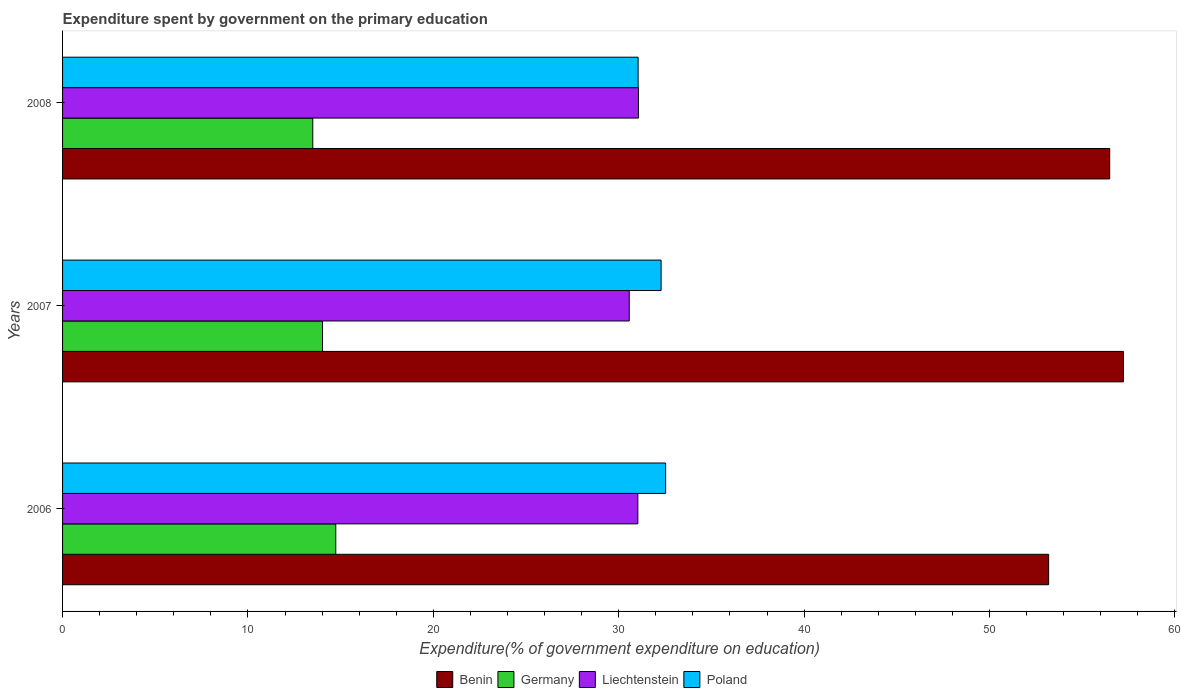How many groups of bars are there?
Give a very brief answer. 3. Are the number of bars on each tick of the Y-axis equal?
Give a very brief answer. Yes. What is the label of the 3rd group of bars from the top?
Ensure brevity in your answer.  2006. In how many cases, is the number of bars for a given year not equal to the number of legend labels?
Offer a terse response. 0. What is the expenditure spent by government on the primary education in Germany in 2006?
Your answer should be very brief. 14.74. Across all years, what is the maximum expenditure spent by government on the primary education in Liechtenstein?
Give a very brief answer. 31.06. Across all years, what is the minimum expenditure spent by government on the primary education in Benin?
Keep it short and to the point. 53.19. In which year was the expenditure spent by government on the primary education in Germany maximum?
Your answer should be compact. 2006. What is the total expenditure spent by government on the primary education in Germany in the graph?
Keep it short and to the point. 42.26. What is the difference between the expenditure spent by government on the primary education in Poland in 2006 and that in 2007?
Your response must be concise. 0.24. What is the difference between the expenditure spent by government on the primary education in Poland in 2006 and the expenditure spent by government on the primary education in Benin in 2007?
Provide a short and direct response. -24.7. What is the average expenditure spent by government on the primary education in Germany per year?
Your answer should be very brief. 14.09. In the year 2008, what is the difference between the expenditure spent by government on the primary education in Poland and expenditure spent by government on the primary education in Benin?
Keep it short and to the point. -25.44. What is the ratio of the expenditure spent by government on the primary education in Benin in 2007 to that in 2008?
Provide a short and direct response. 1.01. Is the difference between the expenditure spent by government on the primary education in Poland in 2006 and 2007 greater than the difference between the expenditure spent by government on the primary education in Benin in 2006 and 2007?
Your answer should be compact. Yes. What is the difference between the highest and the second highest expenditure spent by government on the primary education in Liechtenstein?
Offer a terse response. 0.03. What is the difference between the highest and the lowest expenditure spent by government on the primary education in Benin?
Your response must be concise. 4.04. In how many years, is the expenditure spent by government on the primary education in Benin greater than the average expenditure spent by government on the primary education in Benin taken over all years?
Ensure brevity in your answer.  2. Is the sum of the expenditure spent by government on the primary education in Benin in 2006 and 2008 greater than the maximum expenditure spent by government on the primary education in Poland across all years?
Offer a terse response. Yes. Is it the case that in every year, the sum of the expenditure spent by government on the primary education in Benin and expenditure spent by government on the primary education in Poland is greater than the sum of expenditure spent by government on the primary education in Liechtenstein and expenditure spent by government on the primary education in Germany?
Ensure brevity in your answer.  No. What does the 1st bar from the top in 2006 represents?
Keep it short and to the point. Poland. What does the 4th bar from the bottom in 2006 represents?
Your answer should be very brief. Poland. Is it the case that in every year, the sum of the expenditure spent by government on the primary education in Germany and expenditure spent by government on the primary education in Benin is greater than the expenditure spent by government on the primary education in Liechtenstein?
Provide a succinct answer. Yes. Are all the bars in the graph horizontal?
Give a very brief answer. Yes. How many years are there in the graph?
Offer a terse response. 3. Where does the legend appear in the graph?
Provide a short and direct response. Bottom center. How are the legend labels stacked?
Make the answer very short. Horizontal. What is the title of the graph?
Your response must be concise. Expenditure spent by government on the primary education. What is the label or title of the X-axis?
Provide a succinct answer. Expenditure(% of government expenditure on education). What is the Expenditure(% of government expenditure on education) in Benin in 2006?
Give a very brief answer. 53.19. What is the Expenditure(% of government expenditure on education) in Germany in 2006?
Offer a terse response. 14.74. What is the Expenditure(% of government expenditure on education) of Liechtenstein in 2006?
Provide a short and direct response. 31.03. What is the Expenditure(% of government expenditure on education) in Poland in 2006?
Ensure brevity in your answer.  32.53. What is the Expenditure(% of government expenditure on education) of Benin in 2007?
Provide a succinct answer. 57.23. What is the Expenditure(% of government expenditure on education) in Germany in 2007?
Ensure brevity in your answer.  14.02. What is the Expenditure(% of government expenditure on education) in Liechtenstein in 2007?
Keep it short and to the point. 30.57. What is the Expenditure(% of government expenditure on education) of Poland in 2007?
Offer a very short reply. 32.29. What is the Expenditure(% of government expenditure on education) of Benin in 2008?
Your answer should be very brief. 56.49. What is the Expenditure(% of government expenditure on education) in Germany in 2008?
Provide a short and direct response. 13.5. What is the Expenditure(% of government expenditure on education) in Liechtenstein in 2008?
Offer a terse response. 31.06. What is the Expenditure(% of government expenditure on education) in Poland in 2008?
Provide a succinct answer. 31.05. Across all years, what is the maximum Expenditure(% of government expenditure on education) in Benin?
Offer a terse response. 57.23. Across all years, what is the maximum Expenditure(% of government expenditure on education) in Germany?
Offer a very short reply. 14.74. Across all years, what is the maximum Expenditure(% of government expenditure on education) in Liechtenstein?
Your answer should be very brief. 31.06. Across all years, what is the maximum Expenditure(% of government expenditure on education) in Poland?
Ensure brevity in your answer.  32.53. Across all years, what is the minimum Expenditure(% of government expenditure on education) of Benin?
Your answer should be compact. 53.19. Across all years, what is the minimum Expenditure(% of government expenditure on education) in Germany?
Make the answer very short. 13.5. Across all years, what is the minimum Expenditure(% of government expenditure on education) of Liechtenstein?
Offer a very short reply. 30.57. Across all years, what is the minimum Expenditure(% of government expenditure on education) in Poland?
Provide a short and direct response. 31.05. What is the total Expenditure(% of government expenditure on education) in Benin in the graph?
Provide a succinct answer. 166.91. What is the total Expenditure(% of government expenditure on education) in Germany in the graph?
Keep it short and to the point. 42.26. What is the total Expenditure(% of government expenditure on education) of Liechtenstein in the graph?
Offer a terse response. 92.67. What is the total Expenditure(% of government expenditure on education) in Poland in the graph?
Offer a terse response. 95.87. What is the difference between the Expenditure(% of government expenditure on education) in Benin in 2006 and that in 2007?
Your response must be concise. -4.04. What is the difference between the Expenditure(% of government expenditure on education) in Germany in 2006 and that in 2007?
Ensure brevity in your answer.  0.71. What is the difference between the Expenditure(% of government expenditure on education) of Liechtenstein in 2006 and that in 2007?
Make the answer very short. 0.46. What is the difference between the Expenditure(% of government expenditure on education) in Poland in 2006 and that in 2007?
Your answer should be very brief. 0.24. What is the difference between the Expenditure(% of government expenditure on education) of Benin in 2006 and that in 2008?
Offer a terse response. -3.29. What is the difference between the Expenditure(% of government expenditure on education) in Germany in 2006 and that in 2008?
Give a very brief answer. 1.24. What is the difference between the Expenditure(% of government expenditure on education) in Liechtenstein in 2006 and that in 2008?
Offer a terse response. -0.03. What is the difference between the Expenditure(% of government expenditure on education) of Poland in 2006 and that in 2008?
Your response must be concise. 1.48. What is the difference between the Expenditure(% of government expenditure on education) of Benin in 2007 and that in 2008?
Make the answer very short. 0.74. What is the difference between the Expenditure(% of government expenditure on education) in Germany in 2007 and that in 2008?
Keep it short and to the point. 0.53. What is the difference between the Expenditure(% of government expenditure on education) of Liechtenstein in 2007 and that in 2008?
Your answer should be very brief. -0.5. What is the difference between the Expenditure(% of government expenditure on education) of Poland in 2007 and that in 2008?
Offer a very short reply. 1.24. What is the difference between the Expenditure(% of government expenditure on education) of Benin in 2006 and the Expenditure(% of government expenditure on education) of Germany in 2007?
Make the answer very short. 39.17. What is the difference between the Expenditure(% of government expenditure on education) of Benin in 2006 and the Expenditure(% of government expenditure on education) of Liechtenstein in 2007?
Provide a short and direct response. 22.62. What is the difference between the Expenditure(% of government expenditure on education) in Benin in 2006 and the Expenditure(% of government expenditure on education) in Poland in 2007?
Offer a very short reply. 20.91. What is the difference between the Expenditure(% of government expenditure on education) of Germany in 2006 and the Expenditure(% of government expenditure on education) of Liechtenstein in 2007?
Offer a terse response. -15.83. What is the difference between the Expenditure(% of government expenditure on education) of Germany in 2006 and the Expenditure(% of government expenditure on education) of Poland in 2007?
Provide a succinct answer. -17.55. What is the difference between the Expenditure(% of government expenditure on education) in Liechtenstein in 2006 and the Expenditure(% of government expenditure on education) in Poland in 2007?
Provide a short and direct response. -1.25. What is the difference between the Expenditure(% of government expenditure on education) in Benin in 2006 and the Expenditure(% of government expenditure on education) in Germany in 2008?
Your response must be concise. 39.7. What is the difference between the Expenditure(% of government expenditure on education) in Benin in 2006 and the Expenditure(% of government expenditure on education) in Liechtenstein in 2008?
Offer a terse response. 22.13. What is the difference between the Expenditure(% of government expenditure on education) of Benin in 2006 and the Expenditure(% of government expenditure on education) of Poland in 2008?
Ensure brevity in your answer.  22.14. What is the difference between the Expenditure(% of government expenditure on education) of Germany in 2006 and the Expenditure(% of government expenditure on education) of Liechtenstein in 2008?
Provide a succinct answer. -16.33. What is the difference between the Expenditure(% of government expenditure on education) in Germany in 2006 and the Expenditure(% of government expenditure on education) in Poland in 2008?
Provide a short and direct response. -16.31. What is the difference between the Expenditure(% of government expenditure on education) in Liechtenstein in 2006 and the Expenditure(% of government expenditure on education) in Poland in 2008?
Your answer should be very brief. -0.02. What is the difference between the Expenditure(% of government expenditure on education) in Benin in 2007 and the Expenditure(% of government expenditure on education) in Germany in 2008?
Give a very brief answer. 43.73. What is the difference between the Expenditure(% of government expenditure on education) in Benin in 2007 and the Expenditure(% of government expenditure on education) in Liechtenstein in 2008?
Keep it short and to the point. 26.16. What is the difference between the Expenditure(% of government expenditure on education) of Benin in 2007 and the Expenditure(% of government expenditure on education) of Poland in 2008?
Your answer should be compact. 26.18. What is the difference between the Expenditure(% of government expenditure on education) of Germany in 2007 and the Expenditure(% of government expenditure on education) of Liechtenstein in 2008?
Offer a terse response. -17.04. What is the difference between the Expenditure(% of government expenditure on education) in Germany in 2007 and the Expenditure(% of government expenditure on education) in Poland in 2008?
Your response must be concise. -17.02. What is the difference between the Expenditure(% of government expenditure on education) in Liechtenstein in 2007 and the Expenditure(% of government expenditure on education) in Poland in 2008?
Ensure brevity in your answer.  -0.48. What is the average Expenditure(% of government expenditure on education) in Benin per year?
Make the answer very short. 55.64. What is the average Expenditure(% of government expenditure on education) of Germany per year?
Offer a terse response. 14.09. What is the average Expenditure(% of government expenditure on education) in Liechtenstein per year?
Your answer should be compact. 30.89. What is the average Expenditure(% of government expenditure on education) of Poland per year?
Offer a very short reply. 31.95. In the year 2006, what is the difference between the Expenditure(% of government expenditure on education) in Benin and Expenditure(% of government expenditure on education) in Germany?
Ensure brevity in your answer.  38.45. In the year 2006, what is the difference between the Expenditure(% of government expenditure on education) of Benin and Expenditure(% of government expenditure on education) of Liechtenstein?
Provide a succinct answer. 22.16. In the year 2006, what is the difference between the Expenditure(% of government expenditure on education) in Benin and Expenditure(% of government expenditure on education) in Poland?
Your response must be concise. 20.66. In the year 2006, what is the difference between the Expenditure(% of government expenditure on education) in Germany and Expenditure(% of government expenditure on education) in Liechtenstein?
Make the answer very short. -16.29. In the year 2006, what is the difference between the Expenditure(% of government expenditure on education) in Germany and Expenditure(% of government expenditure on education) in Poland?
Provide a succinct answer. -17.79. In the year 2006, what is the difference between the Expenditure(% of government expenditure on education) of Liechtenstein and Expenditure(% of government expenditure on education) of Poland?
Your answer should be very brief. -1.5. In the year 2007, what is the difference between the Expenditure(% of government expenditure on education) in Benin and Expenditure(% of government expenditure on education) in Germany?
Keep it short and to the point. 43.2. In the year 2007, what is the difference between the Expenditure(% of government expenditure on education) of Benin and Expenditure(% of government expenditure on education) of Liechtenstein?
Provide a succinct answer. 26.66. In the year 2007, what is the difference between the Expenditure(% of government expenditure on education) in Benin and Expenditure(% of government expenditure on education) in Poland?
Your answer should be very brief. 24.94. In the year 2007, what is the difference between the Expenditure(% of government expenditure on education) in Germany and Expenditure(% of government expenditure on education) in Liechtenstein?
Your answer should be very brief. -16.54. In the year 2007, what is the difference between the Expenditure(% of government expenditure on education) in Germany and Expenditure(% of government expenditure on education) in Poland?
Your answer should be very brief. -18.26. In the year 2007, what is the difference between the Expenditure(% of government expenditure on education) of Liechtenstein and Expenditure(% of government expenditure on education) of Poland?
Ensure brevity in your answer.  -1.72. In the year 2008, what is the difference between the Expenditure(% of government expenditure on education) of Benin and Expenditure(% of government expenditure on education) of Germany?
Provide a succinct answer. 42.99. In the year 2008, what is the difference between the Expenditure(% of government expenditure on education) in Benin and Expenditure(% of government expenditure on education) in Liechtenstein?
Your answer should be very brief. 25.42. In the year 2008, what is the difference between the Expenditure(% of government expenditure on education) of Benin and Expenditure(% of government expenditure on education) of Poland?
Make the answer very short. 25.44. In the year 2008, what is the difference between the Expenditure(% of government expenditure on education) of Germany and Expenditure(% of government expenditure on education) of Liechtenstein?
Ensure brevity in your answer.  -17.57. In the year 2008, what is the difference between the Expenditure(% of government expenditure on education) in Germany and Expenditure(% of government expenditure on education) in Poland?
Keep it short and to the point. -17.55. In the year 2008, what is the difference between the Expenditure(% of government expenditure on education) in Liechtenstein and Expenditure(% of government expenditure on education) in Poland?
Offer a very short reply. 0.02. What is the ratio of the Expenditure(% of government expenditure on education) in Benin in 2006 to that in 2007?
Your answer should be very brief. 0.93. What is the ratio of the Expenditure(% of government expenditure on education) in Germany in 2006 to that in 2007?
Provide a succinct answer. 1.05. What is the ratio of the Expenditure(% of government expenditure on education) in Liechtenstein in 2006 to that in 2007?
Ensure brevity in your answer.  1.02. What is the ratio of the Expenditure(% of government expenditure on education) in Poland in 2006 to that in 2007?
Ensure brevity in your answer.  1.01. What is the ratio of the Expenditure(% of government expenditure on education) of Benin in 2006 to that in 2008?
Offer a terse response. 0.94. What is the ratio of the Expenditure(% of government expenditure on education) in Germany in 2006 to that in 2008?
Offer a terse response. 1.09. What is the ratio of the Expenditure(% of government expenditure on education) in Poland in 2006 to that in 2008?
Your response must be concise. 1.05. What is the ratio of the Expenditure(% of government expenditure on education) of Benin in 2007 to that in 2008?
Provide a short and direct response. 1.01. What is the ratio of the Expenditure(% of government expenditure on education) in Germany in 2007 to that in 2008?
Make the answer very short. 1.04. What is the ratio of the Expenditure(% of government expenditure on education) in Poland in 2007 to that in 2008?
Ensure brevity in your answer.  1.04. What is the difference between the highest and the second highest Expenditure(% of government expenditure on education) of Benin?
Provide a succinct answer. 0.74. What is the difference between the highest and the second highest Expenditure(% of government expenditure on education) of Germany?
Offer a very short reply. 0.71. What is the difference between the highest and the second highest Expenditure(% of government expenditure on education) in Liechtenstein?
Offer a terse response. 0.03. What is the difference between the highest and the second highest Expenditure(% of government expenditure on education) of Poland?
Ensure brevity in your answer.  0.24. What is the difference between the highest and the lowest Expenditure(% of government expenditure on education) in Benin?
Your answer should be compact. 4.04. What is the difference between the highest and the lowest Expenditure(% of government expenditure on education) of Germany?
Offer a very short reply. 1.24. What is the difference between the highest and the lowest Expenditure(% of government expenditure on education) of Liechtenstein?
Ensure brevity in your answer.  0.5. What is the difference between the highest and the lowest Expenditure(% of government expenditure on education) of Poland?
Offer a terse response. 1.48. 